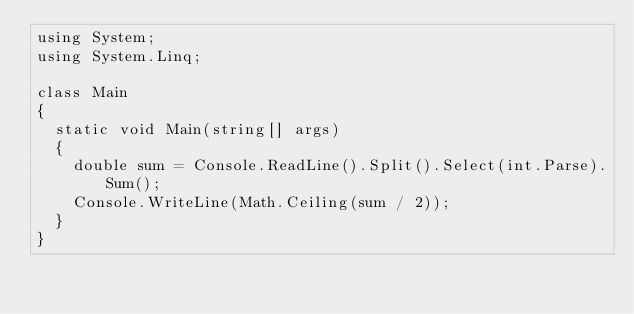<code> <loc_0><loc_0><loc_500><loc_500><_C#_>using System;
using System.Linq;

class Main
{
  static void Main(string[] args)
  {
    double sum = Console.ReadLine().Split().Select(int.Parse).Sum();
    Console.WriteLine(Math.Ceiling(sum / 2));
  }
}</code> 